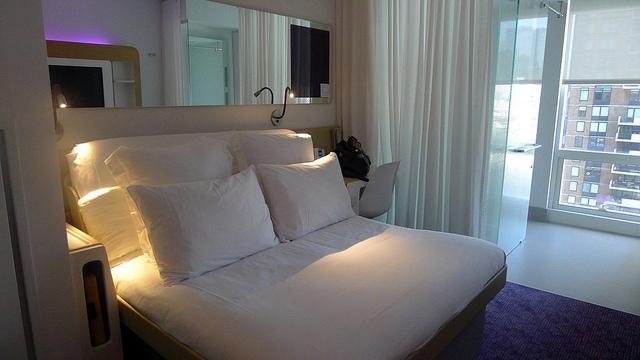Is this room clean?
Write a very short answer. Yes. How many pillows are on the bed?
Write a very short answer. 4. Is there a light turned on?
Short answer required. Yes. 